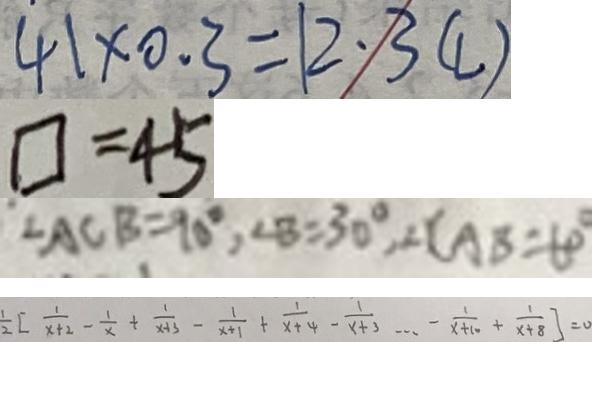<formula> <loc_0><loc_0><loc_500><loc_500>4 1 \times 0 . 3 = 1 2 \cdot 3 ( l ) 
 \square = 4 5 
 \angle A C B = 9 0 ^ { \circ } , \angle B = 3 0 ^ { \circ } , \angle C A B = 6 0 ^ { \circ } 
 \frac { 1 } { 2 } [ \frac { 1 } { x + 2 } - \frac { 1 } { x } + \frac { 1 } { x + 3 } - \frac { 1 } { x + 1 } + \frac { 1 } { x + 4 } - \frac { 1 } { x + 3 } \cdots - \frac { 1 } { x + 1 0 } + \frac { 1 } { x + 8 } ] = 0</formula> 